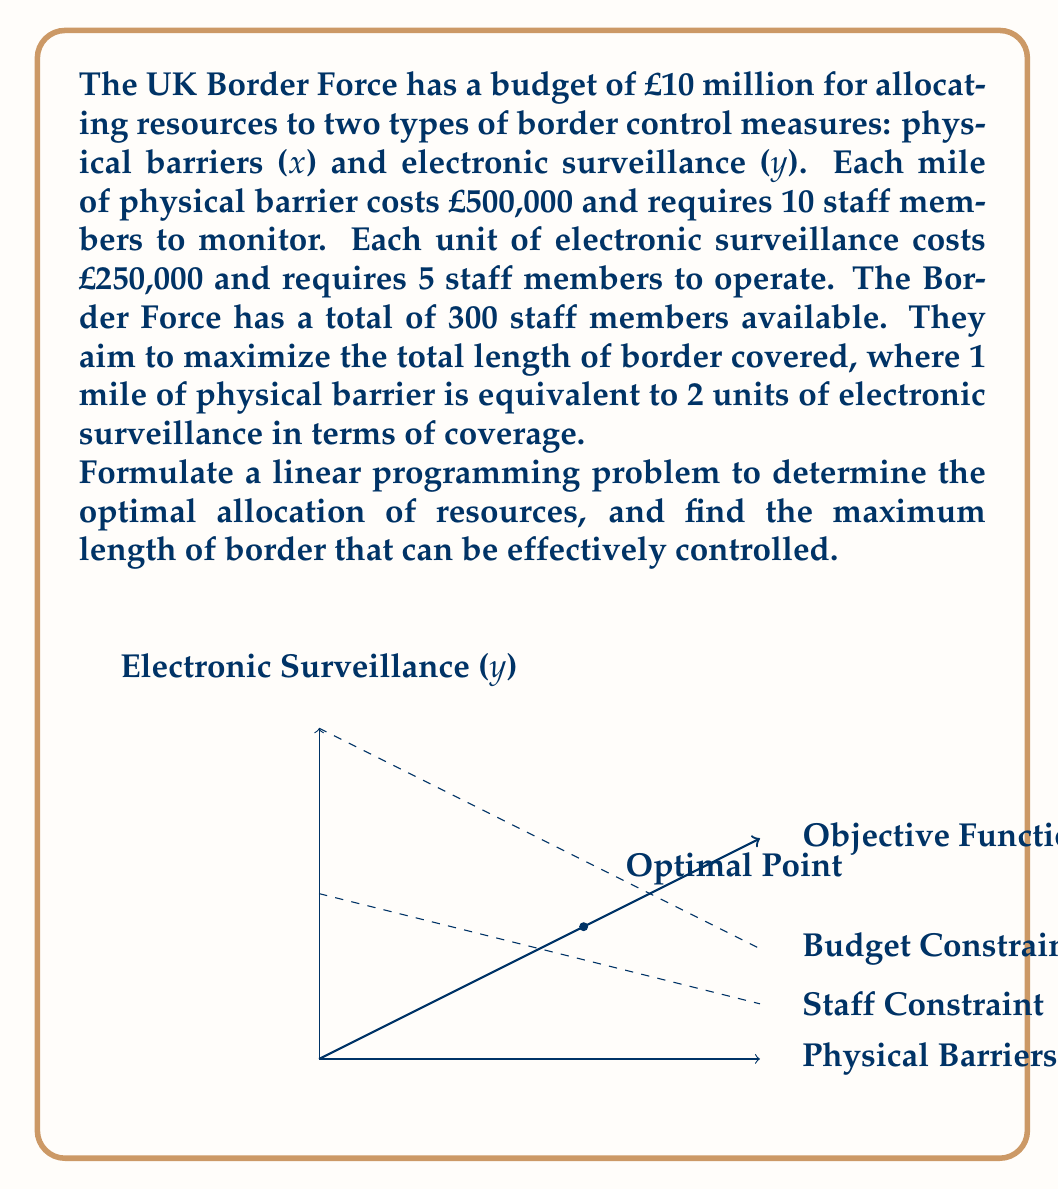Help me with this question. Let's approach this step-by-step:

1) Define variables:
   x = miles of physical barriers
   y = units of electronic surveillance

2) Objective function:
   We want to maximize the total coverage. Since 1 mile of physical barrier is equivalent to 2 units of electronic surveillance:
   Maximize Z = x + 0.5y

3) Constraints:
   a) Budget constraint:
      500000x + 250000y ≤ 10000000
      Simplifying: 2x + y ≤ 40

   b) Staff constraint:
      10x + 5y ≤ 300

4) Non-negativity constraints:
   x ≥ 0, y ≥ 0

5) The linear programming problem:
   Maximize Z = x + 0.5y
   Subject to:
   2x + y ≤ 40
   10x + 5y ≤ 300
   x ≥ 0, y ≥ 0

6) To solve this, we can use the graphical method or the simplex method. Let's use the graphical method:

   a) Plot the constraints:
      2x + y = 40
      10x + 5y = 300

   b) The feasible region is the area bounded by these lines and the axes.

   c) The optimal solution will be at one of the corner points of this region.

   d) The corner points are (0,0), (0,40), (20,0), and the intersection of the two constraint lines.

   e) To find the intersection, solve:
      2x + y = 40
      10x + 5y = 300
      Subtracting 5 times the first equation from the second:
      5y = 100
      y = 20
      Substituting back:
      2x + 20 = 40
      x = 10

   f) So the corner points are (0,0), (0,40), (20,0), and (10,20).

   g) Evaluating the objective function at these points:
      Z(0,0) = 0
      Z(0,40) = 20
      Z(20,0) = 20
      Z(10,20) = 10 + 0.5(20) = 20

7) The maximum value of Z is 20, which can be achieved at (0,40), (20,0), or (10,20).

8) The point (10,20) uses all available resources and provides a balanced approach, so it's likely the preferred solution.

Therefore, the optimal allocation is 10 miles of physical barriers and 20 units of electronic surveillance, providing effective control for 20 miles of border.
Answer: 20 miles 